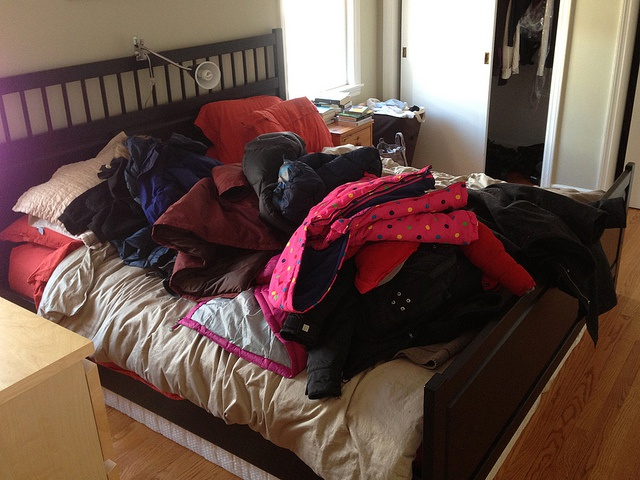Describe the objects in this image and their specific colors. I can see bed in gray, black, and maroon tones, book in gray, white, darkgray, and tan tones, book in gray, darkgray, white, and lightblue tones, and book in gray and darkgray tones in this image. 